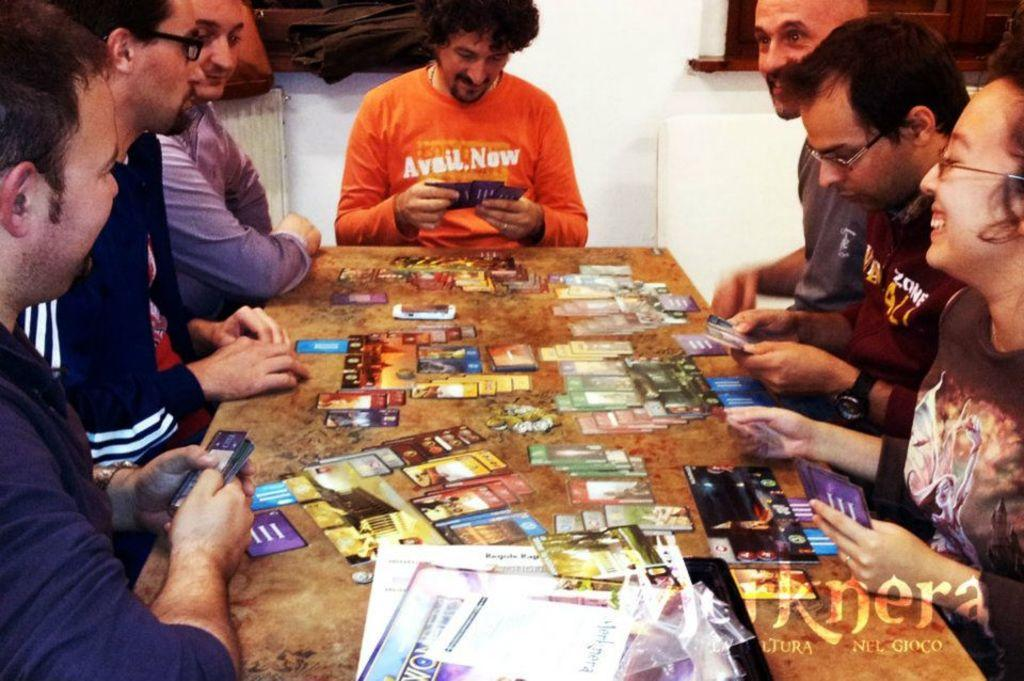What are the people in the image doing? The persons sitting around the table are likely engaged in an activity together. What objects can be seen on the table? There are cards on the table. What can be seen in the background of the image? There is a window and a wall in the background of the image. What type of steel is visible in the image? There is no steel present in the image. How many deer can be seen in the image? There are no deer present in the image. 